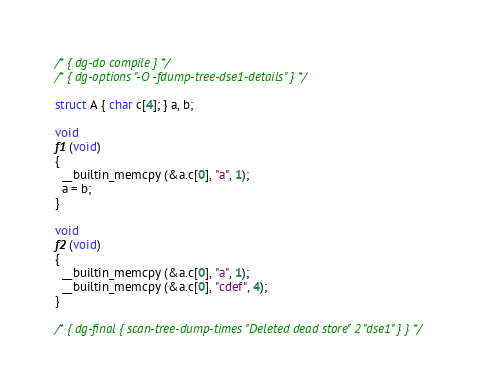Convert code to text. <code><loc_0><loc_0><loc_500><loc_500><_C_>/* { dg-do compile } */
/* { dg-options "-O -fdump-tree-dse1-details" } */

struct A { char c[4]; } a, b;

void
f1 (void)
{
  __builtin_memcpy (&a.c[0], "a", 1);
  a = b;
}

void
f2 (void)
{
  __builtin_memcpy (&a.c[0], "a", 1);
  __builtin_memcpy (&a.c[0], "cdef", 4);
}

/* { dg-final { scan-tree-dump-times "Deleted dead store" 2 "dse1" } } */
</code> 